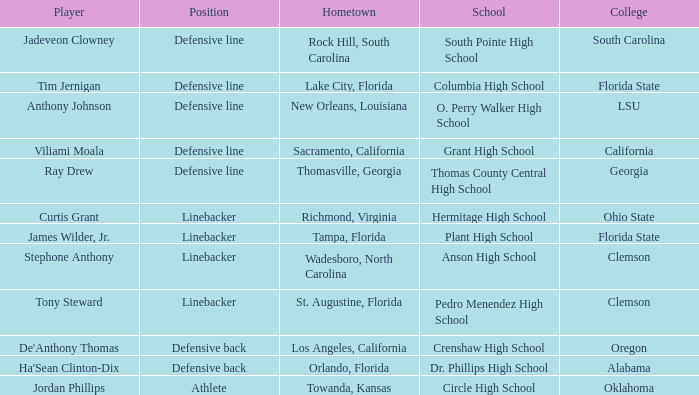Which hometown has a player of Ray Drew? Thomasville, Georgia. 